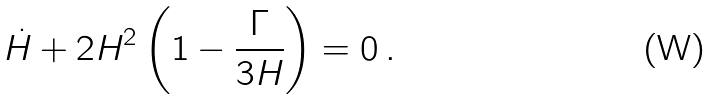<formula> <loc_0><loc_0><loc_500><loc_500>\dot { H } + { 2 } H ^ { 2 } \left ( 1 - \frac { \Gamma } { 3 H } \right ) = 0 \, .</formula> 